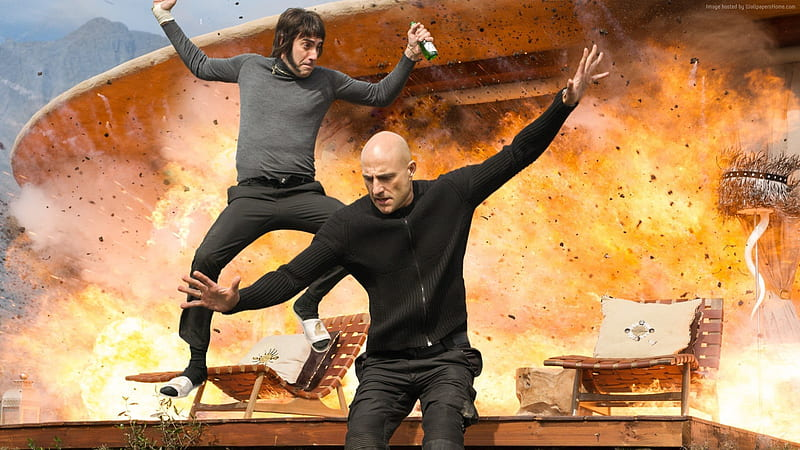Analyze the image in a comprehensive and detailed manner. The image captures two men in a dramatic pose against a backdrop of a massive explosion. Each man is dynamically leaping from a wooden bench; the man on the left wears a dark turtleneck and pants, while the one on the right is dressed in a lighter jumper and darker pants. They both have their arms outstretched, enhancing the energetic feel of the scene. The fiery explosion behind them, rendered in vibrant shades of orange and yellow, adds a thrilling sense of danger and urgency to the image. The clear blue sky above contrasts sharply with the chaos below, further emphasizing the intensity of the moment captured. 